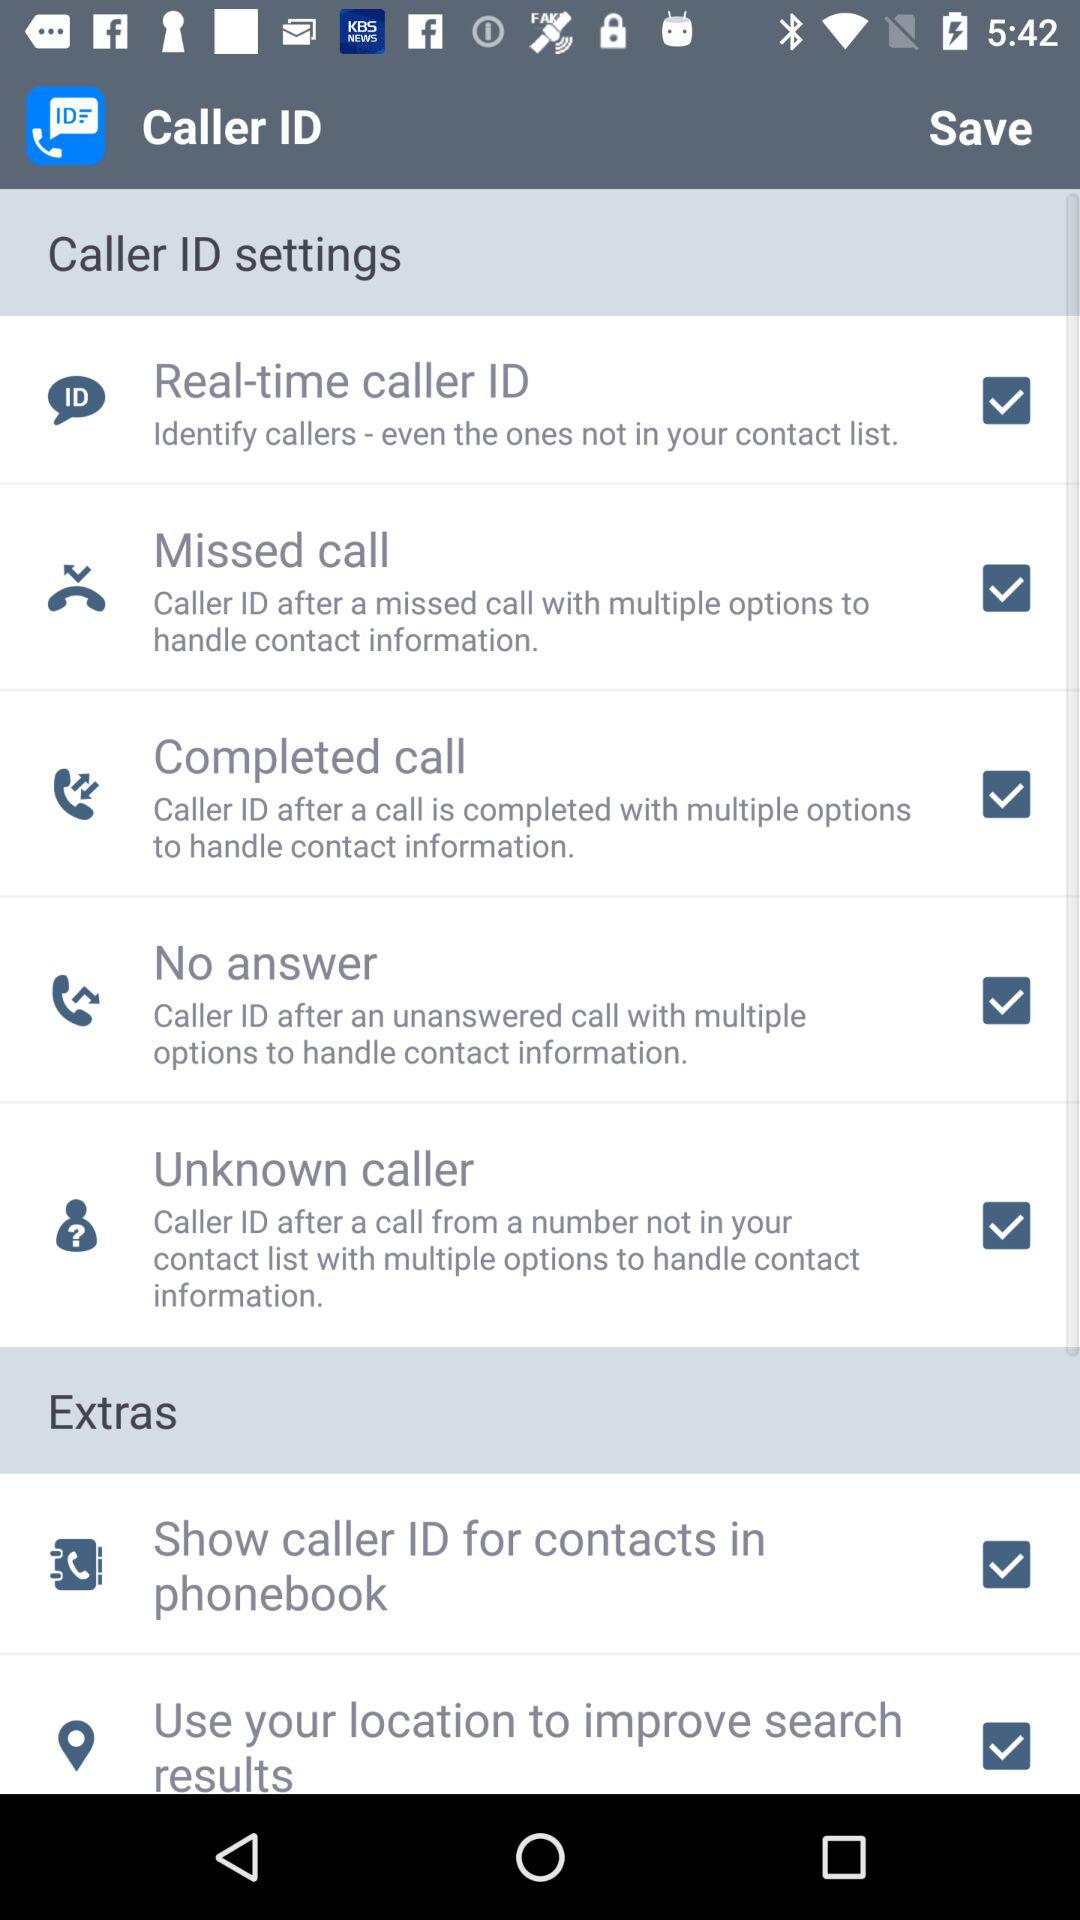What is the status of "Completed call"? The status is "on". 